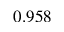<formula> <loc_0><loc_0><loc_500><loc_500>0 . 9 5 8</formula> 